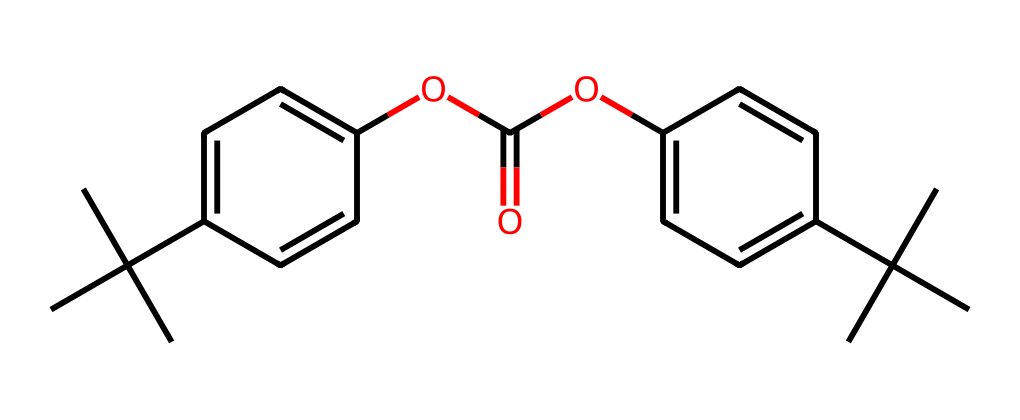What is the overall molecular formula of the compound represented by the SMILES? To deduce the molecular formula, count the number of each type of atom present in the structural representation based on the SMILES. In this case, from the structure, there are 21 carbon (C) atoms, 30 hydrogen (H) atoms, 4 oxygen (O) atoms. Thus, the overall molecular formula is C21H30O4.
Answer: C21H30O4 How many oxygen atoms are present in the chemical? The SMILES indicates that there are four oxygen atoms depicted within the structure of the molecule. By analyzing the count from the SMILES, we find four instances of 'O'.
Answer: 4 What functional group is present in this chemical? The SMILES shows an ester group (as indicated by the -OC(=O)- part of the structure). This identifies the presence of an ester functional group which is typical in polycarbonate materials.
Answer: ester What type of plastic is this compound likely to be? Given that the SMILES represents a polycarbonate due to the presence of aryl groups and carbonate functionalities, this indicates it fits into the category of polycarbonate plastics, known for their durability and impact resistance.
Answer: polycarbonate Which part of the chemical contributes to its transparency? The presence of a conjugated ring system (the aromatic rings) contributes to the transparency of the material as it allows light to pass through without significant scattering, which is valuable in protective eyewear.
Answer: aromatic rings What is the total number of rings in the structure? By analyzing the SMILES representation, you can identify there are two aromatic rings in the compound. Each 'c' in the structure represents a carbon atom in a cyclic form. Thus, the total count of rings is two.
Answer: 2 Which component of the molecule is likely responsible for its impact resistance? The presence of the polycarbonate backbone, particularly the carbonate groups linked to aromatic rings, provides the essential impact-resistant properties typical of polycarbonates. This structure is known for its toughness and resilience.
Answer: carbonate groups 